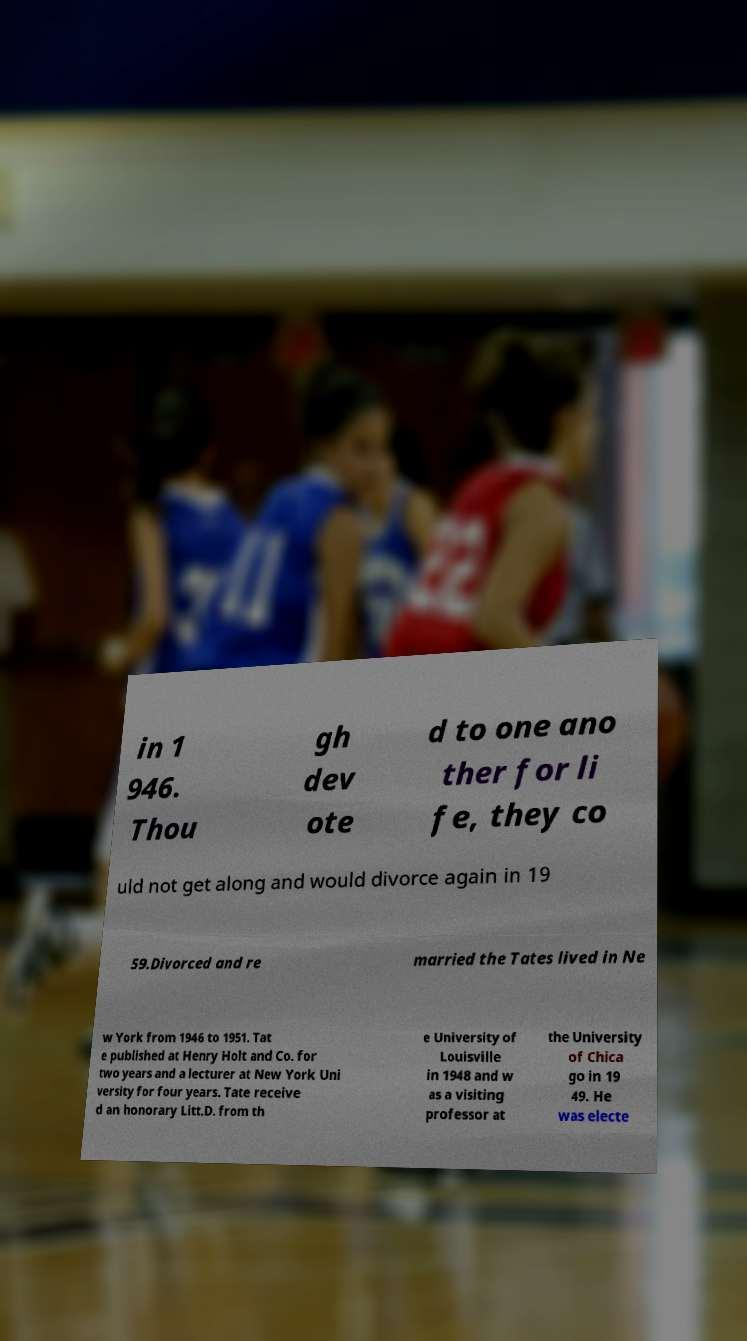Could you assist in decoding the text presented in this image and type it out clearly? in 1 946. Thou gh dev ote d to one ano ther for li fe, they co uld not get along and would divorce again in 19 59.Divorced and re married the Tates lived in Ne w York from 1946 to 1951. Tat e published at Henry Holt and Co. for two years and a lecturer at New York Uni versity for four years. Tate receive d an honorary Litt.D. from th e University of Louisville in 1948 and w as a visiting professor at the University of Chica go in 19 49. He was electe 